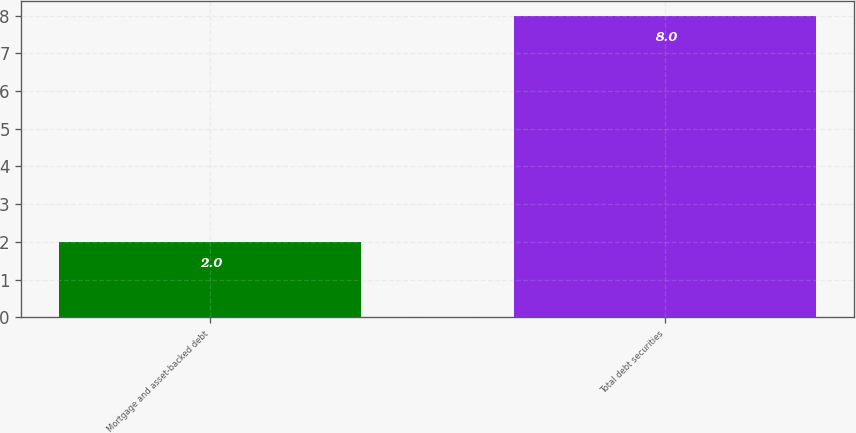<chart> <loc_0><loc_0><loc_500><loc_500><bar_chart><fcel>Mortgage and asset-backed debt<fcel>Total debt securities<nl><fcel>2<fcel>8<nl></chart> 